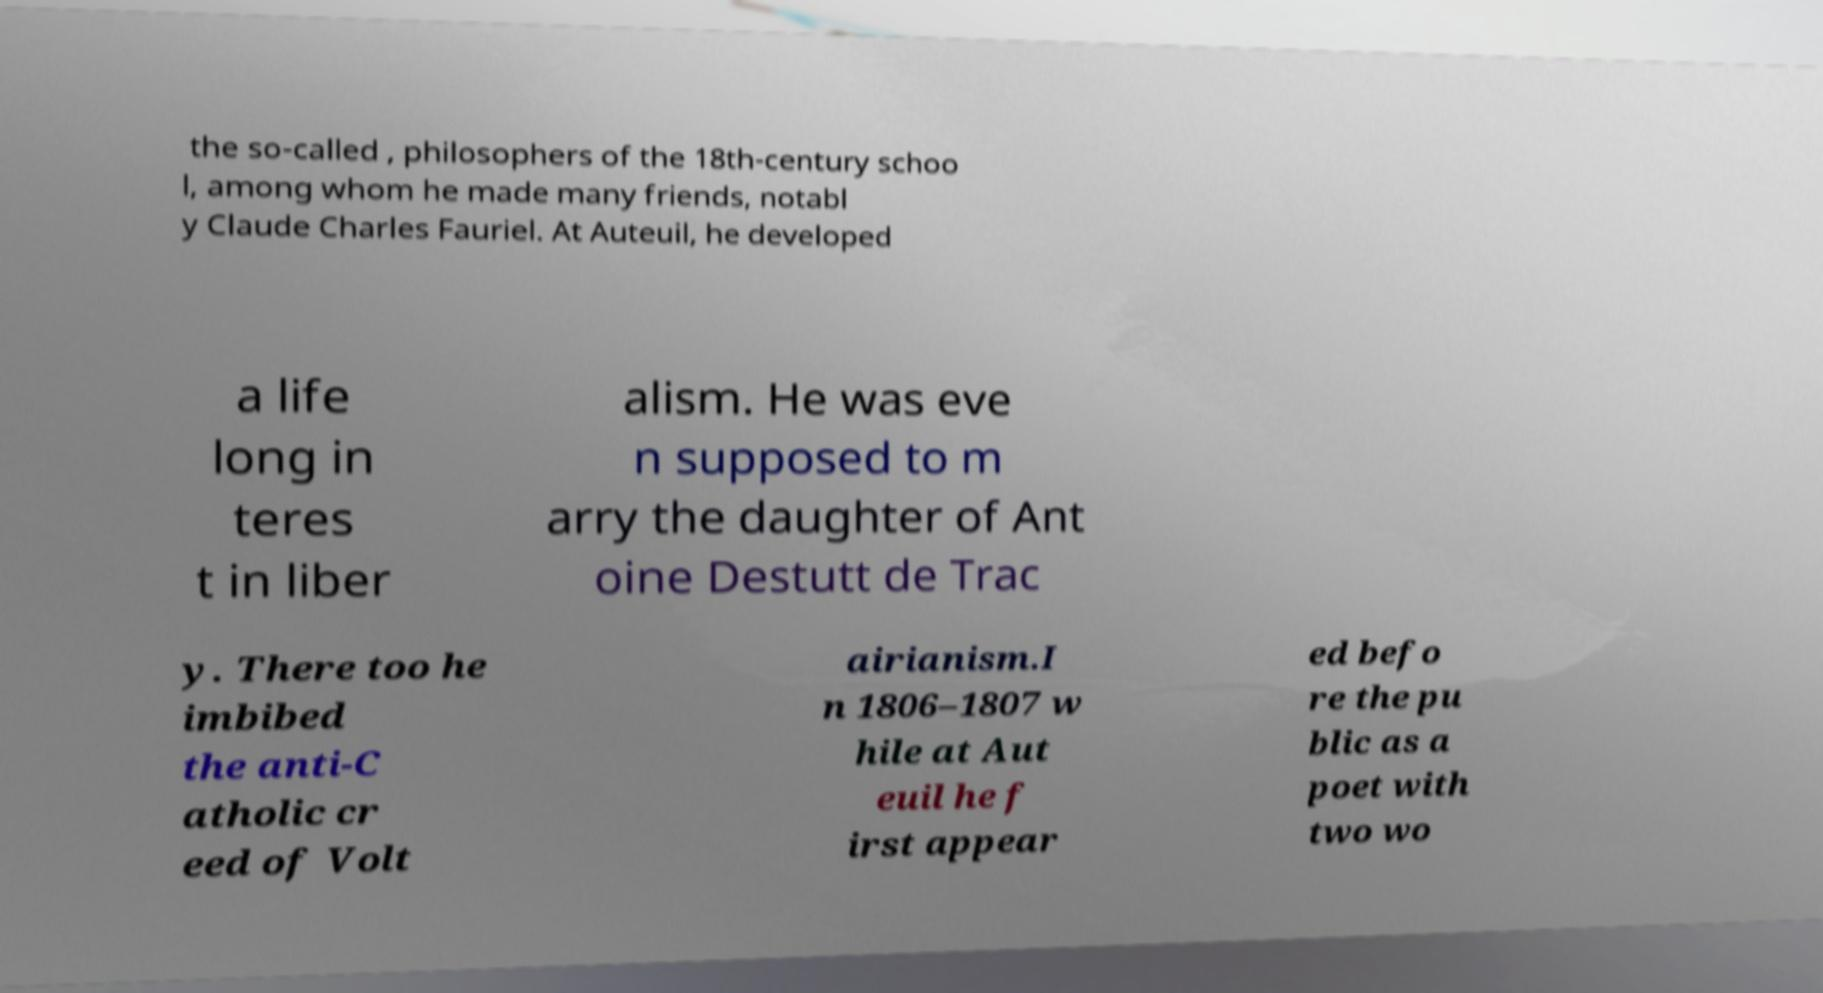There's text embedded in this image that I need extracted. Can you transcribe it verbatim? the so-called , philosophers of the 18th-century schoo l, among whom he made many friends, notabl y Claude Charles Fauriel. At Auteuil, he developed a life long in teres t in liber alism. He was eve n supposed to m arry the daughter of Ant oine Destutt de Trac y. There too he imbibed the anti-C atholic cr eed of Volt airianism.I n 1806–1807 w hile at Aut euil he f irst appear ed befo re the pu blic as a poet with two wo 